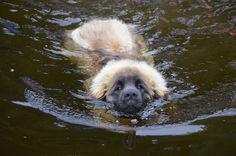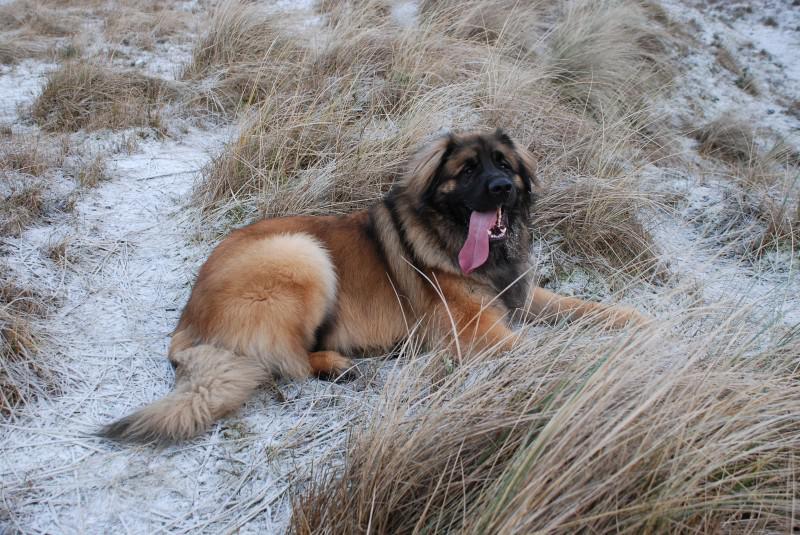The first image is the image on the left, the second image is the image on the right. Considering the images on both sides, is "An image shows one forward-facing dog swimming in a natural body of water." valid? Answer yes or no. Yes. 